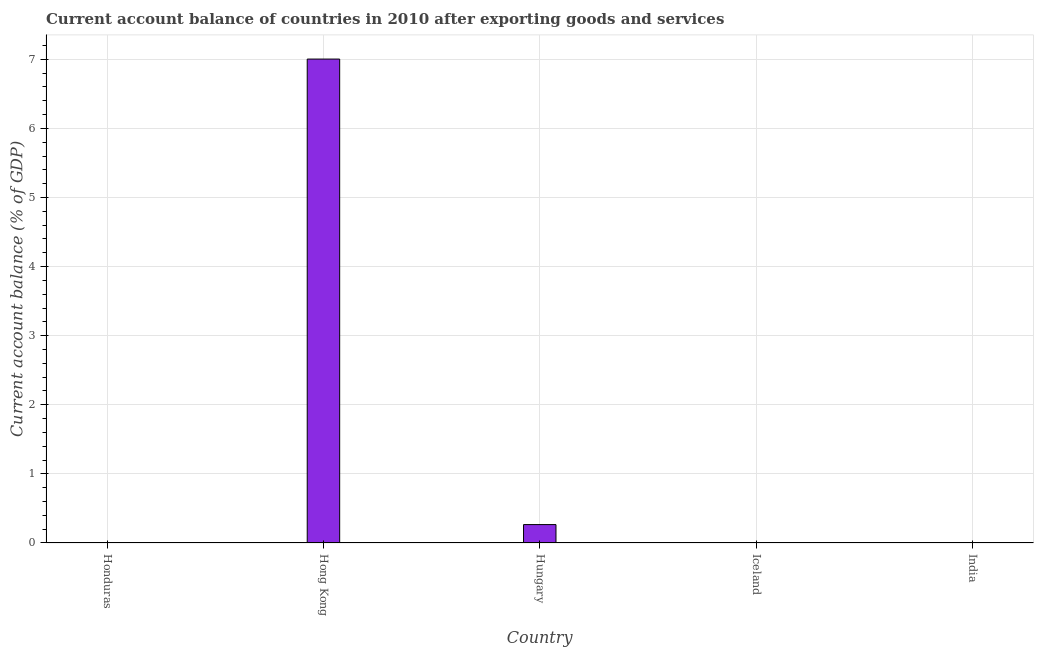Does the graph contain any zero values?
Ensure brevity in your answer.  Yes. What is the title of the graph?
Your answer should be compact. Current account balance of countries in 2010 after exporting goods and services. What is the label or title of the Y-axis?
Your answer should be compact. Current account balance (% of GDP). What is the current account balance in Hong Kong?
Offer a very short reply. 7. Across all countries, what is the maximum current account balance?
Your answer should be very brief. 7. Across all countries, what is the minimum current account balance?
Your response must be concise. 0. In which country was the current account balance maximum?
Provide a short and direct response. Hong Kong. What is the sum of the current account balance?
Your response must be concise. 7.27. What is the difference between the current account balance in Hong Kong and Hungary?
Offer a terse response. 6.74. What is the average current account balance per country?
Make the answer very short. 1.45. What is the median current account balance?
Make the answer very short. 0. In how many countries, is the current account balance greater than 6.6 %?
Your response must be concise. 1. What is the ratio of the current account balance in Hong Kong to that in Hungary?
Provide a short and direct response. 26.31. How many bars are there?
Make the answer very short. 2. How many countries are there in the graph?
Make the answer very short. 5. What is the difference between two consecutive major ticks on the Y-axis?
Ensure brevity in your answer.  1. Are the values on the major ticks of Y-axis written in scientific E-notation?
Ensure brevity in your answer.  No. What is the Current account balance (% of GDP) of Honduras?
Provide a succinct answer. 0. What is the Current account balance (% of GDP) in Hong Kong?
Ensure brevity in your answer.  7. What is the Current account balance (% of GDP) of Hungary?
Ensure brevity in your answer.  0.27. What is the Current account balance (% of GDP) of India?
Your response must be concise. 0. What is the difference between the Current account balance (% of GDP) in Hong Kong and Hungary?
Offer a very short reply. 6.74. What is the ratio of the Current account balance (% of GDP) in Hong Kong to that in Hungary?
Keep it short and to the point. 26.31. 